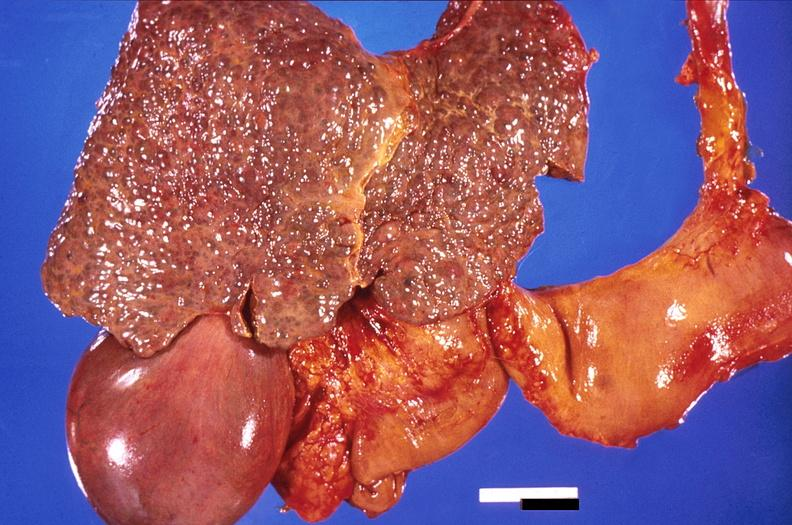does metastatic carcinoma breast show liver, cirrhosis and enlarged gall bladder?
Answer the question using a single word or phrase. No 